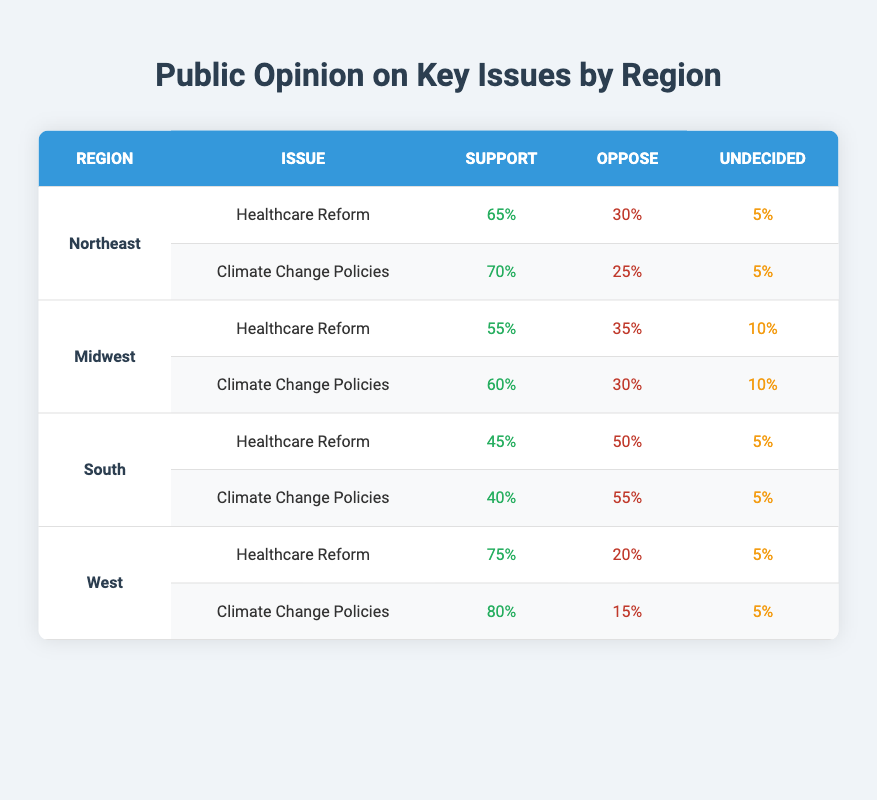What is the support percentage for Healthcare Reform in the Northeast? The table indicates that in the Northeast region, the support percentage for Healthcare Reform is listed directly as 65%.
Answer: 65% Which region shows the highest opposition to Climate Change Policies? Looking at the Climate Change Policies row for each region, the South has the highest opposition percentage listed at 55%.
Answer: South What is the average support percentage for Healthcare Reform across all regions? The support percentages for Healthcare Reform are 65 (Northeast), 55 (Midwest), 45 (South), and 75 (West). The average is calculated as (65 + 55 + 45 + 75) / 4 = 60%.
Answer: 60% Do more people support Climate Change Policies in the West or the Midwest? The support percentages are 80% for the West and 60% for the Midwest. Thus, more people support Climate Change Policies in the West.
Answer: West Is there an undecided percentage for Healthcare Reform in any region? The table shows that all regions have an undecided percentage for Healthcare Reform: 5% in the Northeast and South, and 10% in the Midwest. Thus, the answer is yes.
Answer: Yes What is the difference in support percentage for Climate Change Policies between the West and South? The support percentage for the West is 80% and for the South is 40%. The difference is calculated as 80% - 40% = 40%.
Answer: 40% How many regions have support for Healthcare Reform below 50%? The only region with support below 50% is the South at 45%. Therefore, there is one region with such support.
Answer: 1 Which issue has the highest support percentage in the Midwest? The table shows support percentages in the Midwest: 55% for Healthcare Reform and 60% for Climate Change Policies. Since 60% is higher, Climate Change Policies is the answer.
Answer: Climate Change Policies What is the total support for Healthcare Reform across all regions? The support percentages are 65% (Northeast), 55% (Midwest), 45% (South), and 75% (West). The total is 65 + 55 + 45 + 75 = 240%.
Answer: 240% 